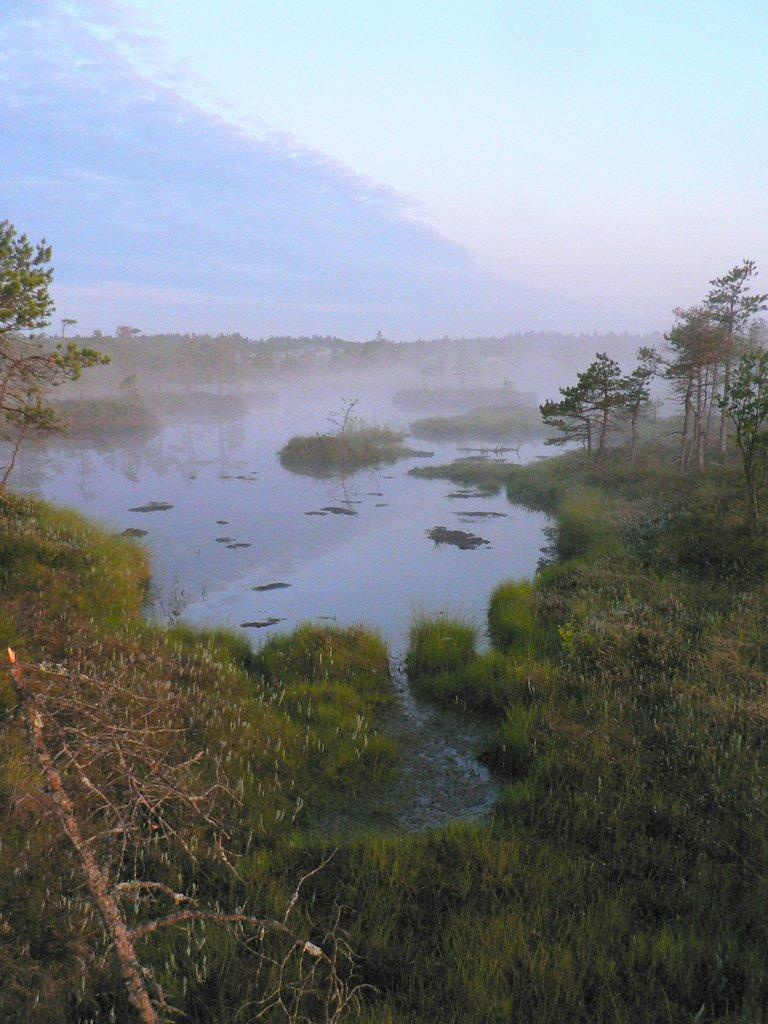What type of vegetation can be seen in the image? There are plants and trees in the image. What natural element is visible in the image? There is water visible in the image. What can be seen in the background of the image? The sky is visible in the background of the image. What is the governor's opinion on the steam coming from the water in the image? There is no governor present in the image, nor is there any steam coming from the water. 